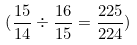<formula> <loc_0><loc_0><loc_500><loc_500>( \frac { 1 5 } { 1 4 } \div \frac { 1 6 } { 1 5 } = \frac { 2 2 5 } { 2 2 4 } )</formula> 